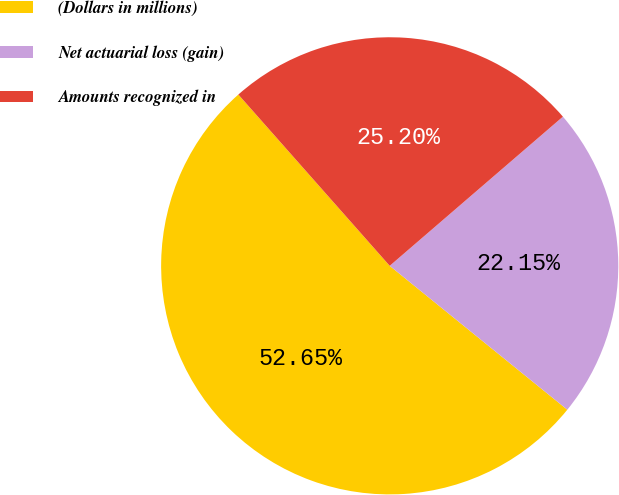<chart> <loc_0><loc_0><loc_500><loc_500><pie_chart><fcel>(Dollars in millions)<fcel>Net actuarial loss (gain)<fcel>Amounts recognized in<nl><fcel>52.64%<fcel>22.15%<fcel>25.2%<nl></chart> 